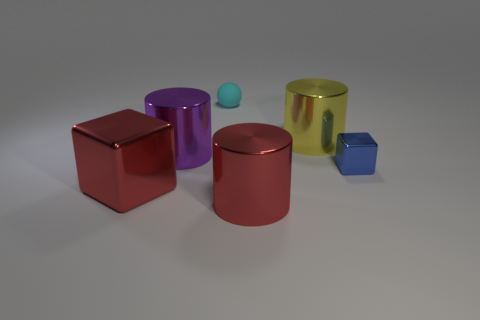Subtract all large red cylinders. How many cylinders are left? 2 Add 4 small metal cylinders. How many objects exist? 10 Subtract 1 cylinders. How many cylinders are left? 2 Subtract all red cylinders. How many cylinders are left? 2 Subtract all cubes. How many objects are left? 4 Subtract all blue balls. Subtract all brown cylinders. How many balls are left? 1 Subtract all tiny blue cubes. Subtract all big red shiny cylinders. How many objects are left? 4 Add 2 yellow cylinders. How many yellow cylinders are left? 3 Add 1 big yellow shiny cylinders. How many big yellow shiny cylinders exist? 2 Subtract 0 cyan cylinders. How many objects are left? 6 